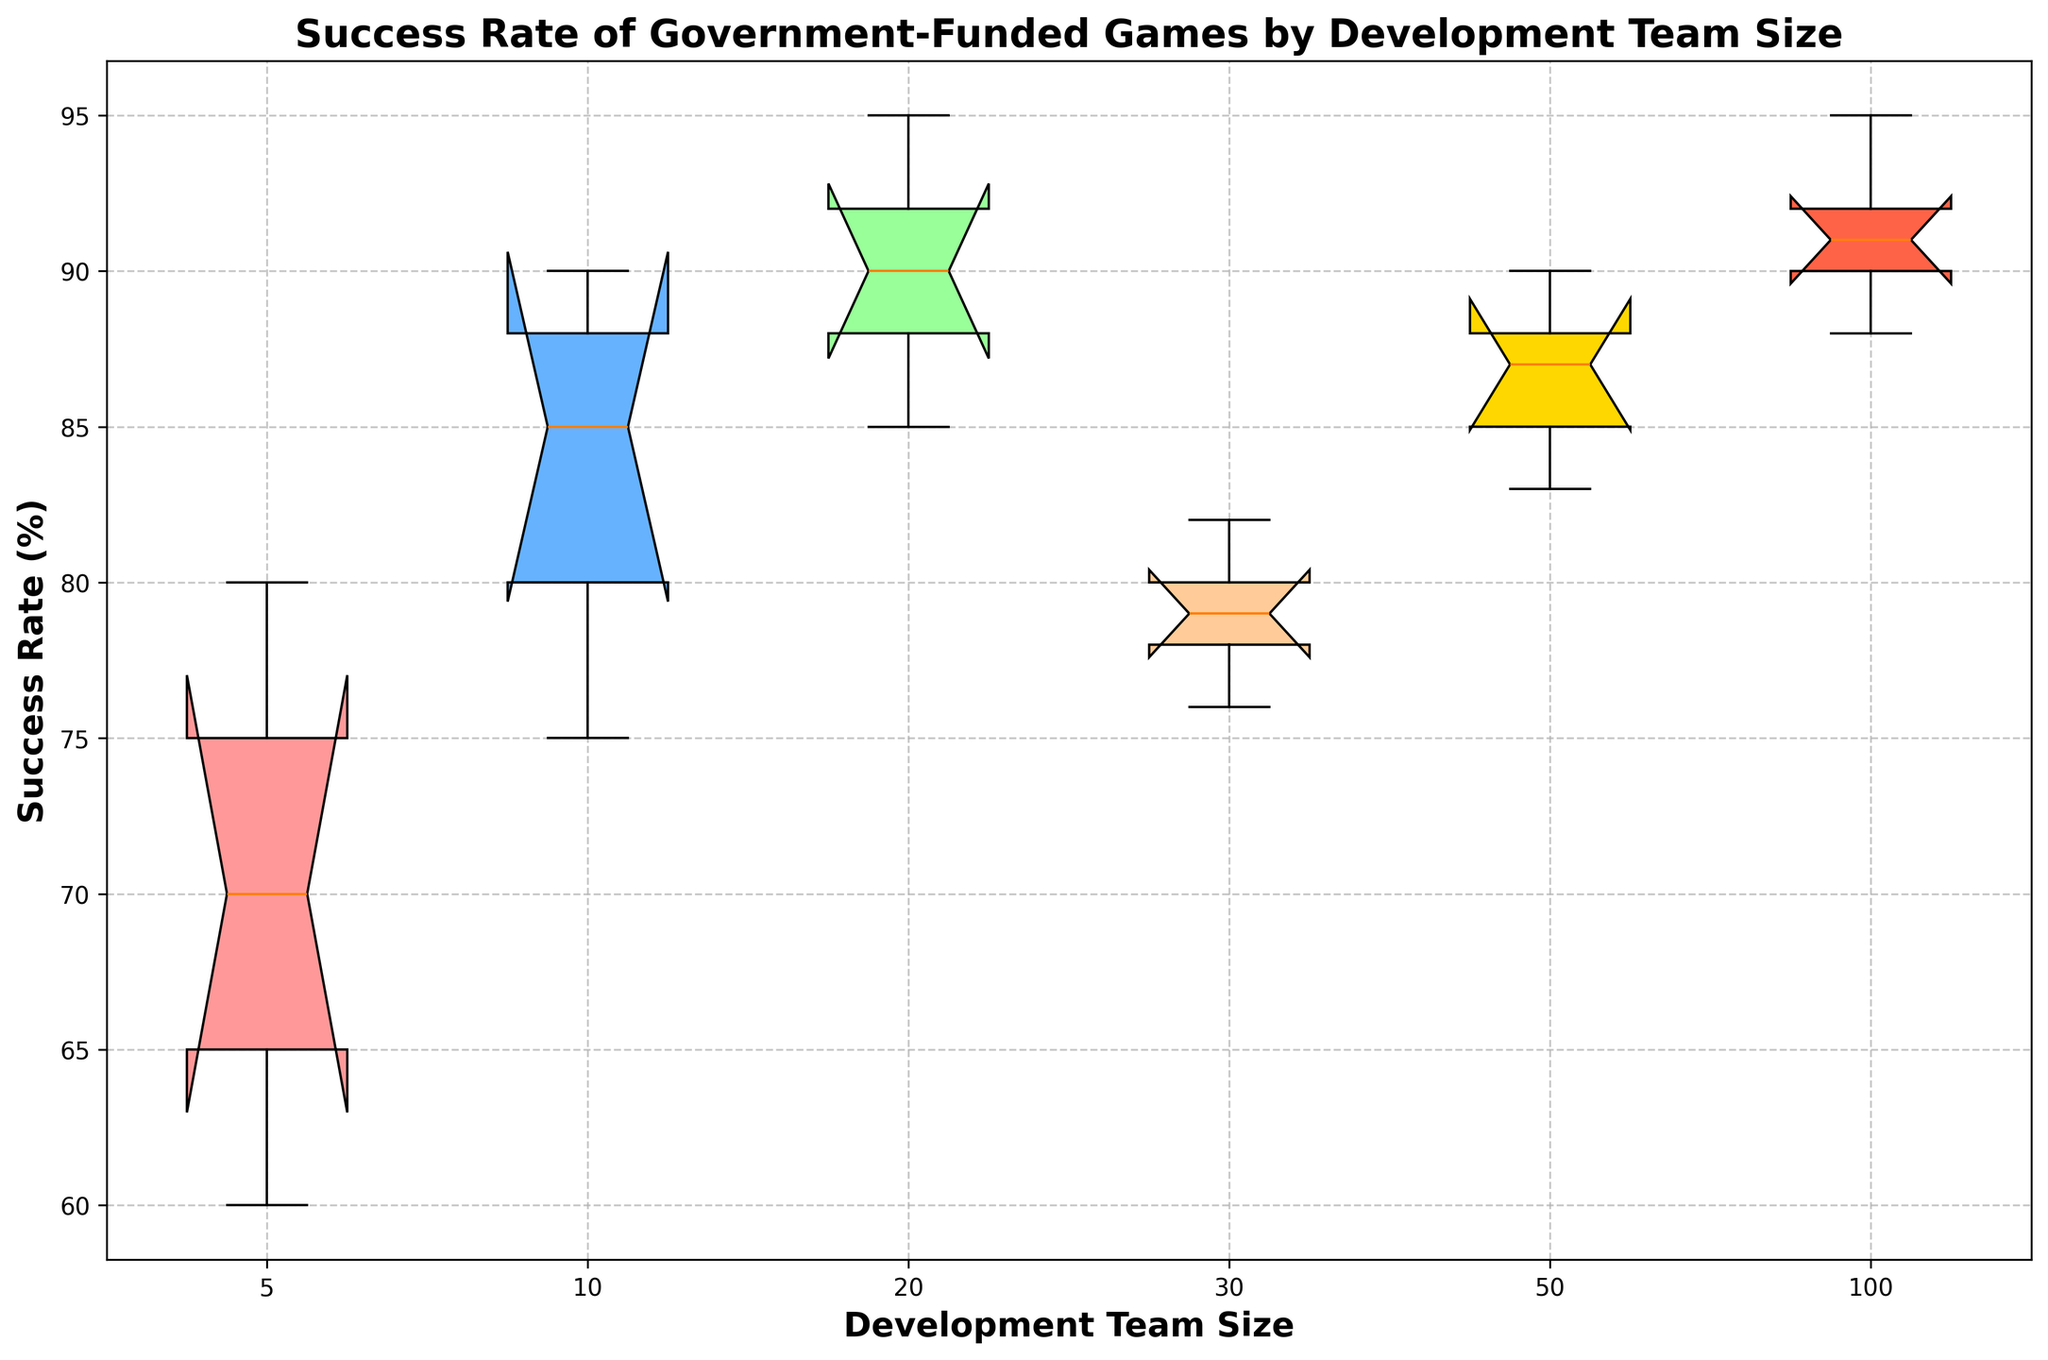Which development team size has the highest median success rate? Look at the median line inside each box; it's the center line. Compare the position of the medians: the 100-member team size has the highest median.
Answer: 100 Which team size shows the greatest spread in success rates? The spread is indicated by the range between the top and bottom whiskers. Among the team sizes, the team with 30 members has the largest spread from 76 to 82.
Answer: 30 How does the median success rate of a 10-member team compare to that of a 20-member team? Locate the median lines for the 10-member and 20-member team sizes. The median for 10 members is slightly lower than that for 20 members.
Answer: Lower What is the range of success rates for the 5-member team size? Look at the distance between the lowest and highest whiskers of the 5-member team size box. The range is from 60 to 80.
Answer: 20 Are there any outliers in the success rates? Outliers are marked as individual points outside the whiskers. The plot does not show individual points beyond whiskers, indicating no outliers.
Answer: No Which development team size has the smallest interquartile range (IQR)? The IQR is the distance between the top and bottom of the box. The team size with 100 members has the smallest IQR.
Answer: 100 What is the interquartile range of success rates for the 50-member team size? Interquartile range is the difference between the upper quartile (Q3) and the lower quartile (Q1). For 50 members, it ranges from around 83 to 90.
Answer: 7 Which two team sizes have the closest median success rates? Compare the median lines across all team sizes. The 10-member and 50-member team sizes have very close medians.
Answer: 10 and 50 How does the success rate of games developed by 20-member teams compare visually to those developed by 5-member teams? The 20-member team box is skewed higher, with a higher minimum, maximum, and median success rate compared to the 5-member team box.
Answer: Higher Are the success rates more consistent for smaller or larger teams? Consistency can be judged by looking at the spread and the presence of outliers. Larger teams (e.g., 100 members) show smaller spread and thus greater consistency in success rates.
Answer: Larger teams 